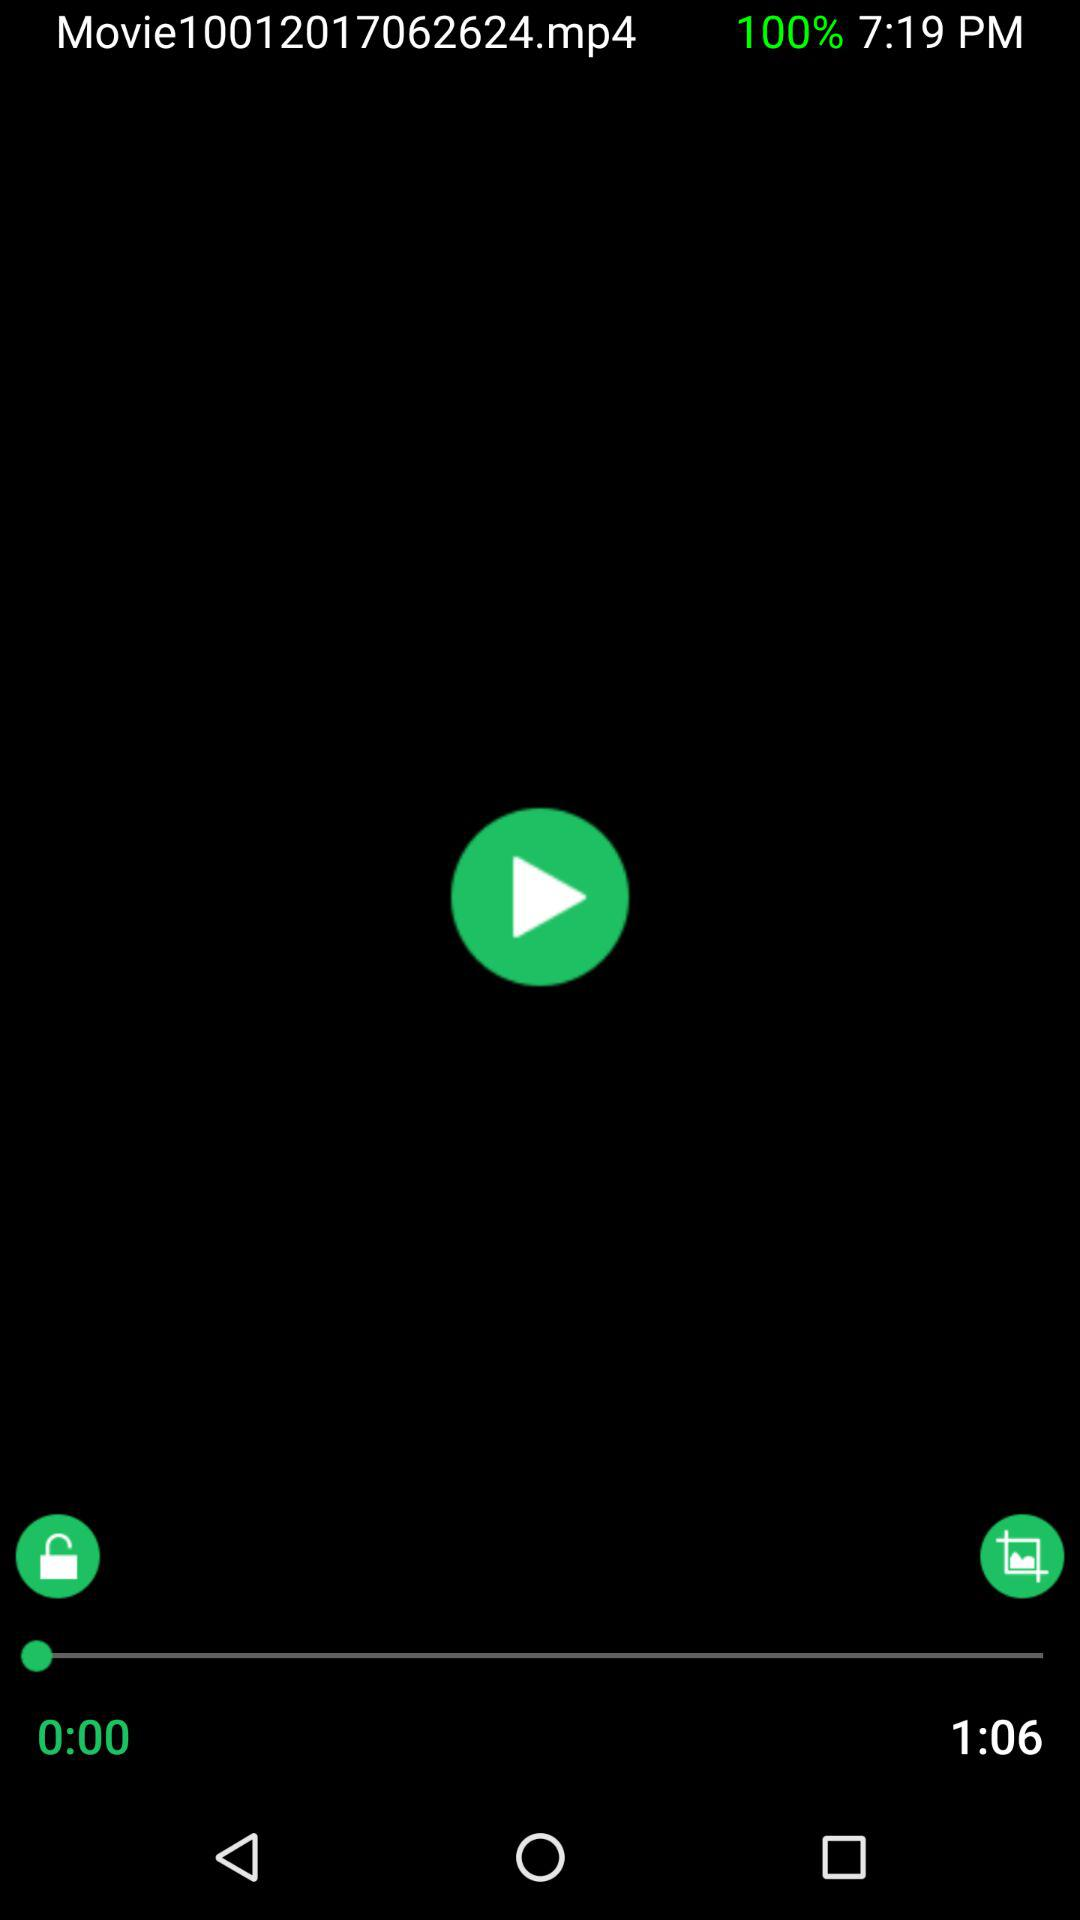Who created "Movie10012017062624.mp4"?
When the provided information is insufficient, respond with <no answer>. <no answer> 